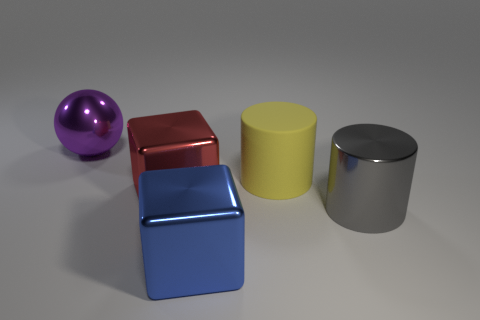Add 2 tiny metal blocks. How many objects exist? 7 Subtract all spheres. How many objects are left? 4 Add 1 large red metallic cubes. How many large red metallic cubes exist? 2 Subtract 0 red balls. How many objects are left? 5 Subtract all purple balls. Subtract all tiny metal things. How many objects are left? 4 Add 2 yellow rubber cylinders. How many yellow rubber cylinders are left? 3 